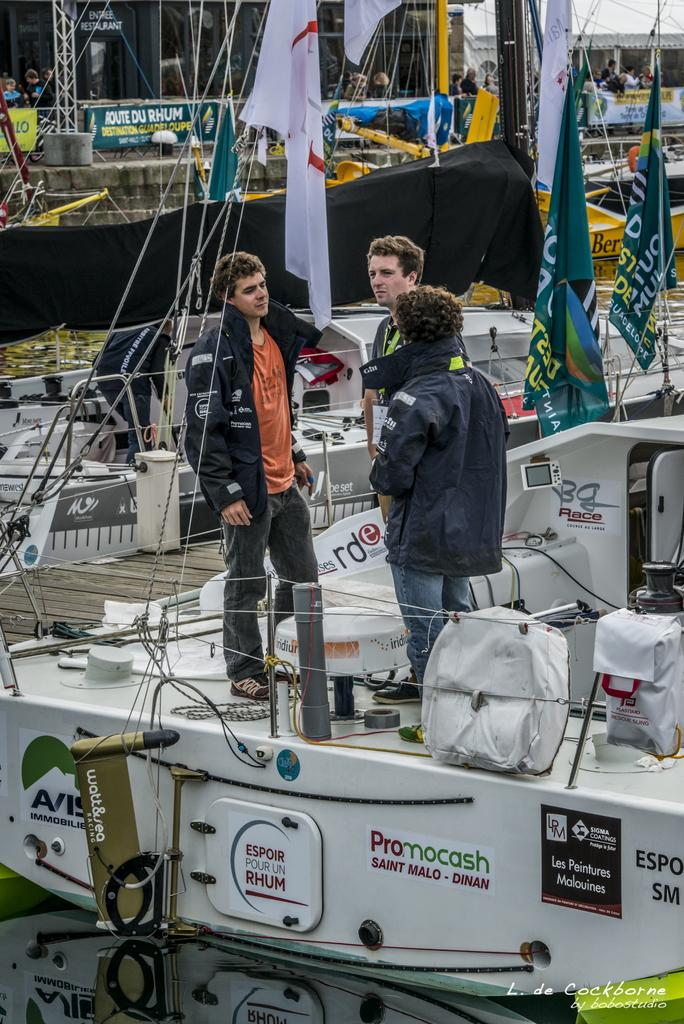What type of vehicles are present in the image? There are boats in the image. What decorative elements can be seen on the boats? There are flags in the image. Who is present in the image? There is a group of people in the image. What additional information is provided in the image? There is some text in the bottom right-hand corner of the image. What is the moon's position in relation to the boats in the image? The moon is not present in the image, so its position cannot be determined. 